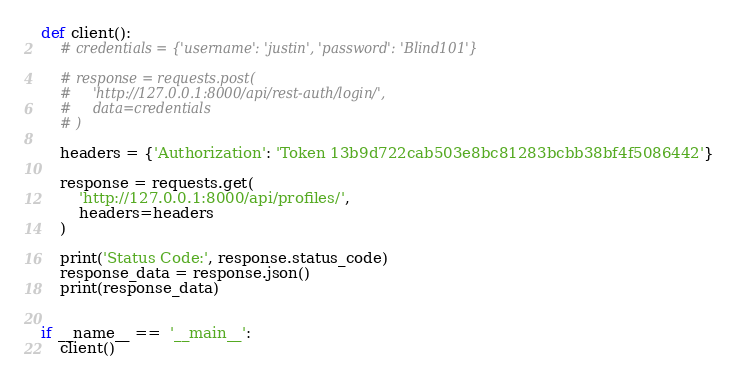Convert code to text. <code><loc_0><loc_0><loc_500><loc_500><_Python_>def client():
    # credentials = {'username': 'justin', 'password': 'Blind101'}

    # response = requests.post(
    #     'http://127.0.0.1:8000/api/rest-auth/login/',
    #     data=credentials
    # )

    headers = {'Authorization': 'Token 13b9d722cab503e8bc81283bcbb38bf4f5086442'}

    response = requests.get(
        'http://127.0.0.1:8000/api/profiles/',
        headers=headers
    )

    print('Status Code:', response.status_code)
    response_data = response.json()
    print(response_data)


if __name__ ==  '__main__':
    client()</code> 